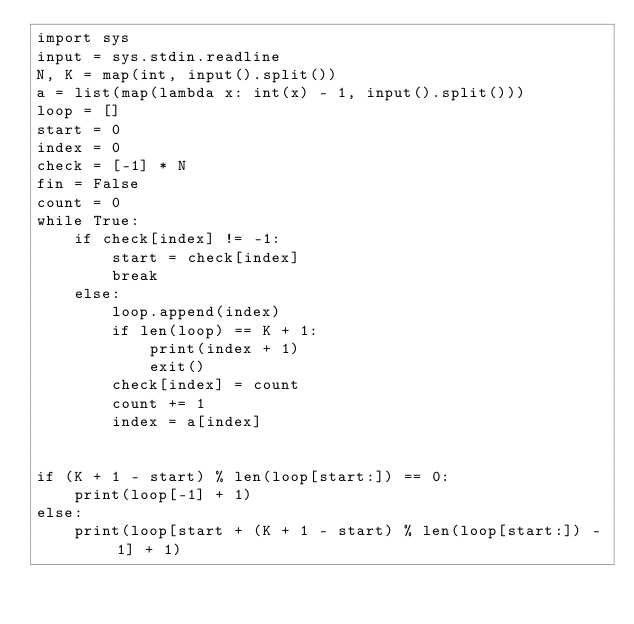<code> <loc_0><loc_0><loc_500><loc_500><_Python_>import sys
input = sys.stdin.readline
N, K = map(int, input().split())
a = list(map(lambda x: int(x) - 1, input().split()))
loop = []
start = 0
index = 0
check = [-1] * N
fin = False
count = 0
while True:
    if check[index] != -1:
        start = check[index]
        break
    else:
        loop.append(index)
        if len(loop) == K + 1:
            print(index + 1)
			exit()
        check[index] = count
        count += 1
        index = a[index]


if (K + 1 - start) % len(loop[start:]) == 0:
    print(loop[-1] + 1)
else:
    print(loop[start + (K + 1 - start) % len(loop[start:]) - 1] + 1)
</code> 